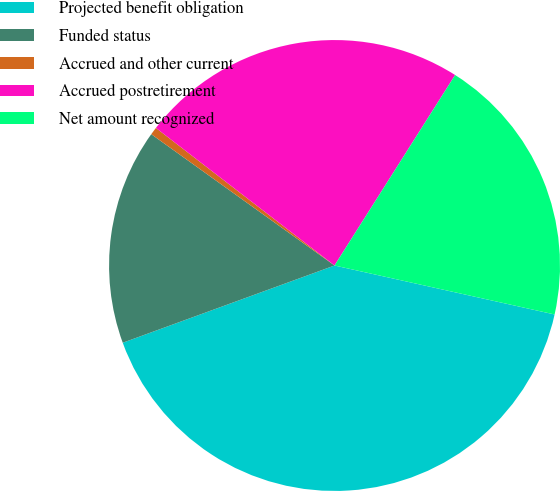<chart> <loc_0><loc_0><loc_500><loc_500><pie_chart><fcel>Projected benefit obligation<fcel>Funded status<fcel>Accrued and other current<fcel>Accrued postretirement<fcel>Net amount recognized<nl><fcel>40.95%<fcel>15.46%<fcel>0.55%<fcel>23.54%<fcel>19.5%<nl></chart> 